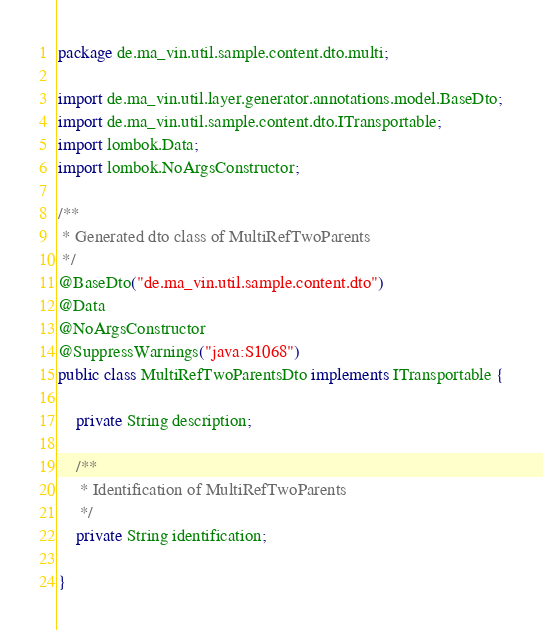<code> <loc_0><loc_0><loc_500><loc_500><_Java_>package de.ma_vin.util.sample.content.dto.multi;

import de.ma_vin.util.layer.generator.annotations.model.BaseDto;
import de.ma_vin.util.sample.content.dto.ITransportable;
import lombok.Data;
import lombok.NoArgsConstructor;

/**
 * Generated dto class of MultiRefTwoParents
 */
@BaseDto("de.ma_vin.util.sample.content.dto")
@Data
@NoArgsConstructor
@SuppressWarnings("java:S1068")
public class MultiRefTwoParentsDto implements ITransportable {

	private String description;

	/**
	 * Identification of MultiRefTwoParents
	 */
	private String identification;

}
</code> 